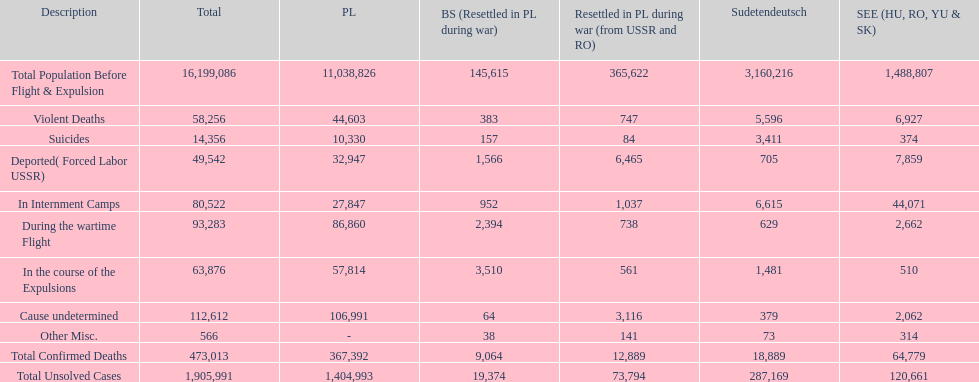Would you mind parsing the complete table? {'header': ['Description', 'Total', 'PL', 'BS (Resettled in PL during war)', 'Resettled in PL during war (from USSR and RO)', 'Sudetendeutsch', 'SEE (HU, RO, YU & SK)'], 'rows': [['Total Population Before Flight & Expulsion', '16,199,086', '11,038,826', '145,615', '365,622', '3,160,216', '1,488,807'], ['Violent Deaths', '58,256', '44,603', '383', '747', '5,596', '6,927'], ['Suicides', '14,356', '10,330', '157', '84', '3,411', '374'], ['Deported( Forced Labor USSR)', '49,542', '32,947', '1,566', '6,465', '705', '7,859'], ['In Internment Camps', '80,522', '27,847', '952', '1,037', '6,615', '44,071'], ['During the wartime Flight', '93,283', '86,860', '2,394', '738', '629', '2,662'], ['In the course of the Expulsions', '63,876', '57,814', '3,510', '561', '1,481', '510'], ['Cause undetermined', '112,612', '106,991', '64', '3,116', '379', '2,062'], ['Other Misc.', '566', '-', '38', '141', '73', '314'], ['Total Confirmed Deaths', '473,013', '367,392', '9,064', '12,889', '18,889', '64,779'], ['Total Unsolved Cases', '1,905,991', '1,404,993', '19,374', '73,794', '287,169', '120,661']]} What is the total of deaths in internment camps and during the wartime flight? 173,805. 